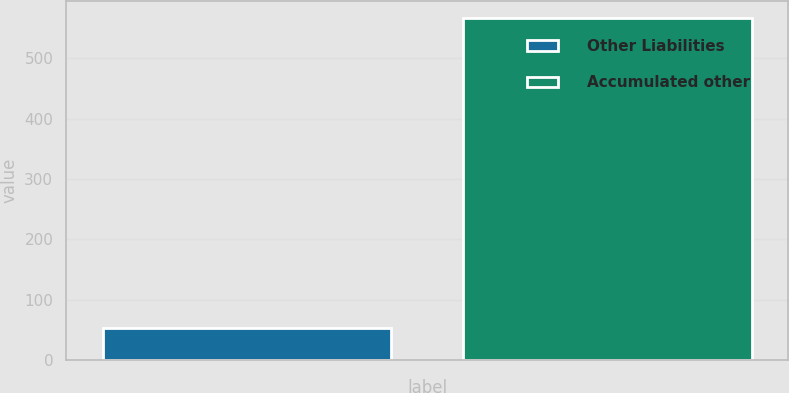Convert chart. <chart><loc_0><loc_0><loc_500><loc_500><bar_chart><fcel>Other Liabilities<fcel>Accumulated other<nl><fcel>52<fcel>567<nl></chart> 